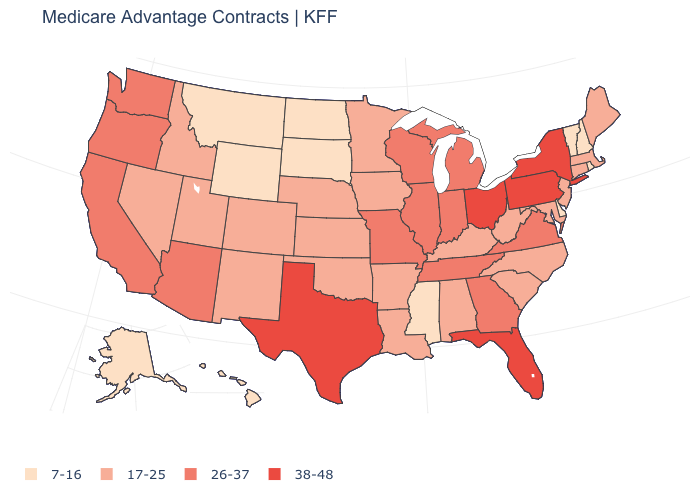Does Florida have a higher value than New York?
Concise answer only. No. Is the legend a continuous bar?
Write a very short answer. No. Does Tennessee have a lower value than New York?
Write a very short answer. Yes. What is the value of New Jersey?
Concise answer only. 17-25. What is the value of Oklahoma?
Quick response, please. 17-25. Name the states that have a value in the range 26-37?
Write a very short answer. Arizona, California, Georgia, Illinois, Indiana, Michigan, Missouri, Oregon, Tennessee, Virginia, Washington, Wisconsin. Name the states that have a value in the range 38-48?
Be succinct. Florida, New York, Ohio, Pennsylvania, Texas. Which states have the lowest value in the USA?
Concise answer only. Alaska, Delaware, Hawaii, Mississippi, Montana, North Dakota, New Hampshire, Rhode Island, South Dakota, Vermont, Wyoming. What is the value of Idaho?
Be succinct. 17-25. What is the value of New Jersey?
Concise answer only. 17-25. Does West Virginia have the same value as Missouri?
Quick response, please. No. Name the states that have a value in the range 17-25?
Give a very brief answer. Alabama, Arkansas, Colorado, Connecticut, Iowa, Idaho, Kansas, Kentucky, Louisiana, Massachusetts, Maryland, Maine, Minnesota, North Carolina, Nebraska, New Jersey, New Mexico, Nevada, Oklahoma, South Carolina, Utah, West Virginia. Is the legend a continuous bar?
Be succinct. No. Among the states that border Arizona , does Nevada have the lowest value?
Give a very brief answer. Yes. Name the states that have a value in the range 7-16?
Keep it brief. Alaska, Delaware, Hawaii, Mississippi, Montana, North Dakota, New Hampshire, Rhode Island, South Dakota, Vermont, Wyoming. 